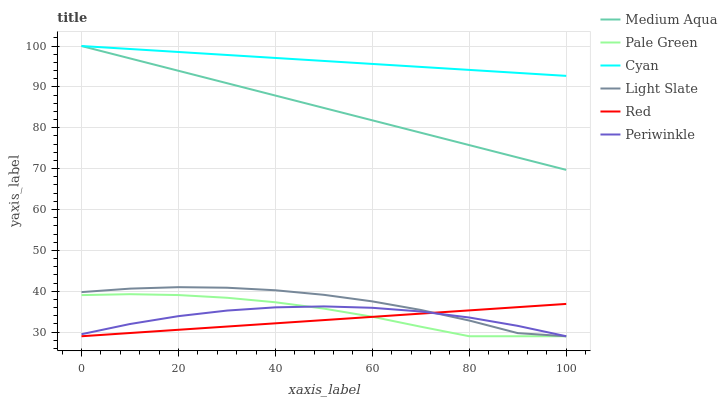Does Red have the minimum area under the curve?
Answer yes or no. Yes. Does Cyan have the maximum area under the curve?
Answer yes or no. Yes. Does Light Slate have the minimum area under the curve?
Answer yes or no. No. Does Light Slate have the maximum area under the curve?
Answer yes or no. No. Is Red the smoothest?
Answer yes or no. Yes. Is Light Slate the roughest?
Answer yes or no. Yes. Is Pale Green the smoothest?
Answer yes or no. No. Is Pale Green the roughest?
Answer yes or no. No. Does Light Slate have the lowest value?
Answer yes or no. Yes. Does Cyan have the lowest value?
Answer yes or no. No. Does Cyan have the highest value?
Answer yes or no. Yes. Does Light Slate have the highest value?
Answer yes or no. No. Is Pale Green less than Medium Aqua?
Answer yes or no. Yes. Is Cyan greater than Light Slate?
Answer yes or no. Yes. Does Cyan intersect Medium Aqua?
Answer yes or no. Yes. Is Cyan less than Medium Aqua?
Answer yes or no. No. Is Cyan greater than Medium Aqua?
Answer yes or no. No. Does Pale Green intersect Medium Aqua?
Answer yes or no. No. 